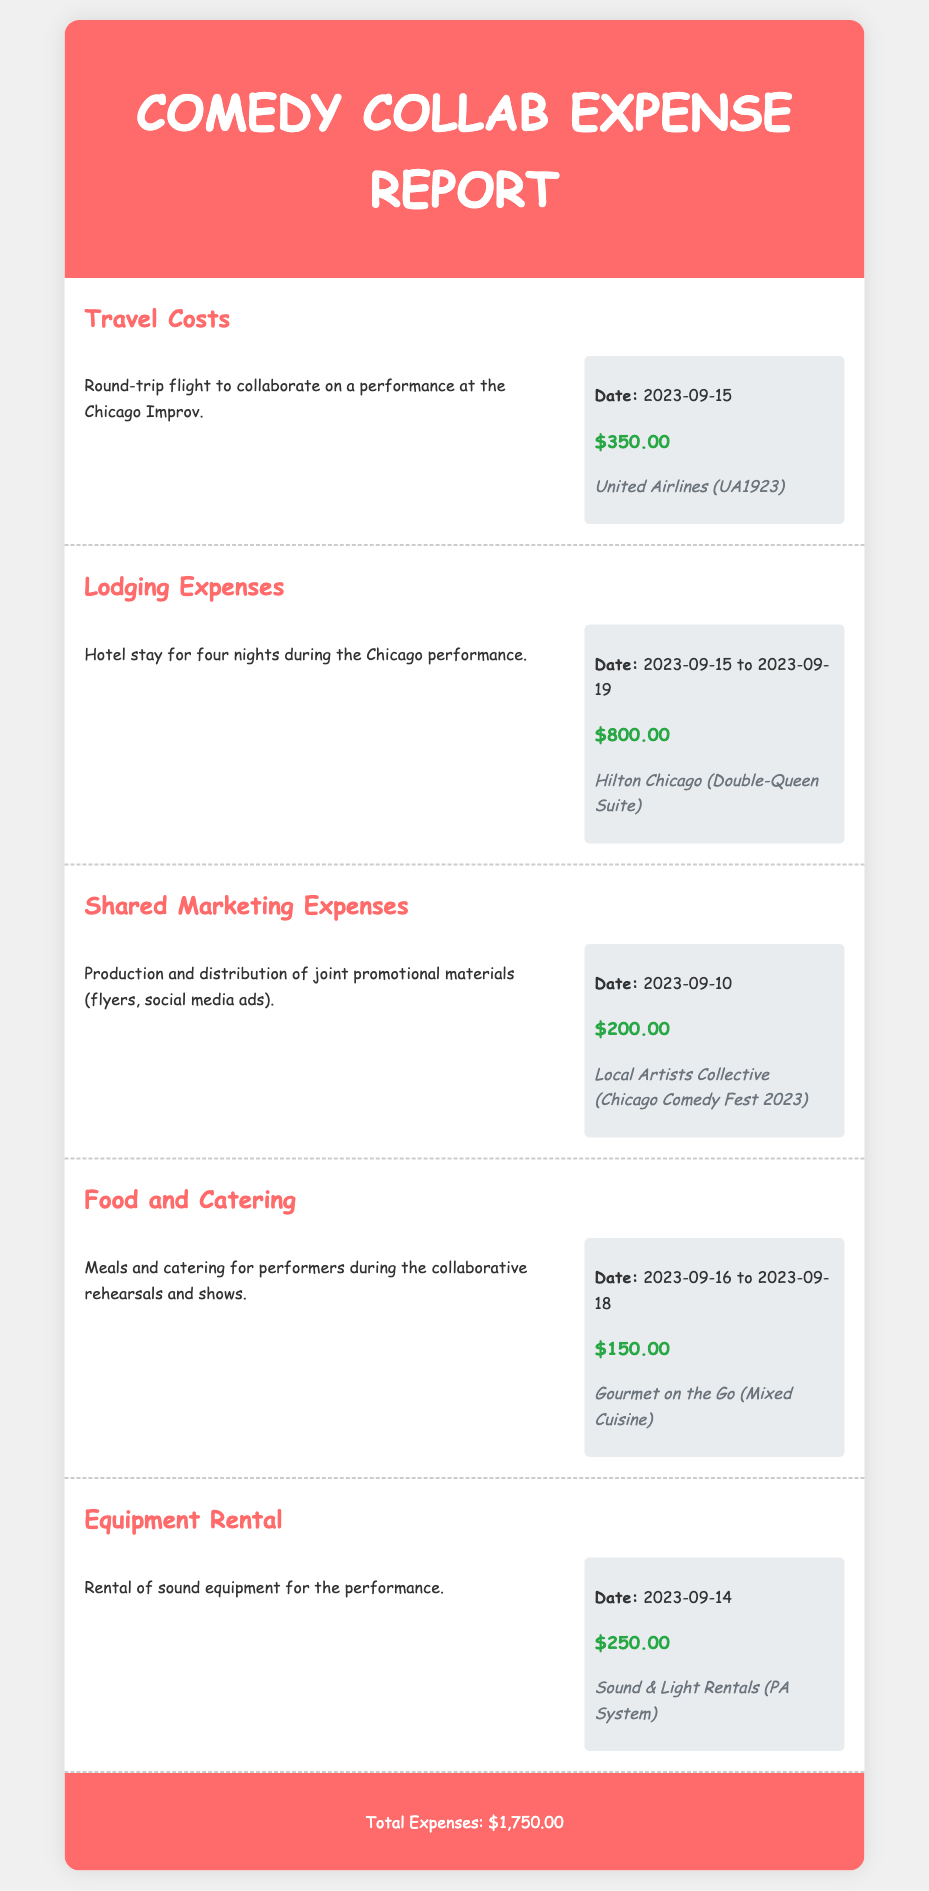What is the total amount of travel costs? The travel costs amount to $350.00 as listed in the document.
Answer: $350.00 What hotel was used for lodging? The lodging was at Hilton Chicago (Double-Queen Suite).
Answer: Hilton Chicago (Double-Queen Suite) For how many nights was lodging incurred? The document states there was a hotel stay for four nights.
Answer: Four nights What is the total cost for shared marketing expenses? The shared marketing expenses are detailed as $200.00.
Answer: $200.00 What is the date range for food and catering expenses? The food and catering expenses were incurred from 2023-09-16 to 2023-09-18.
Answer: 2023-09-16 to 2023-09-18 What type of equipment was rented for the performance? The equipment rented is specified as a PA System.
Answer: PA System What is the total amount for all expenses? The total expenses, according to the footer, is $1,750.00.
Answer: $1,750.00 When was the round-trip flight to Chicago? The flight to Chicago was on 2023-09-15.
Answer: 2023-09-15 Who provided the meals during the collaborative rehearsals? The meals were provided by Gourmet on the Go (Mixed Cuisine).
Answer: Gourmet on the Go (Mixed Cuisine) 